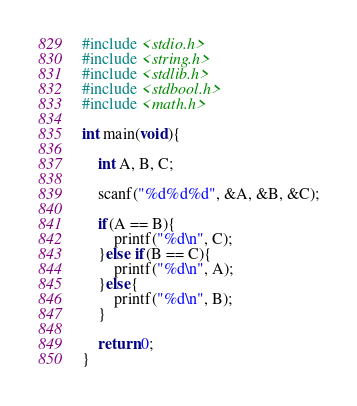<code> <loc_0><loc_0><loc_500><loc_500><_C_>#include <stdio.h>
#include <string.h>
#include <stdlib.h>
#include <stdbool.h>
#include <math.h>

int main(void){

    int A, B, C;

    scanf("%d%d%d", &A, &B, &C);

    if(A == B){
        printf("%d\n", C);
    }else if(B == C){
        printf("%d\n", A);
    }else{
        printf("%d\n", B);
    }

    return 0;
}</code> 